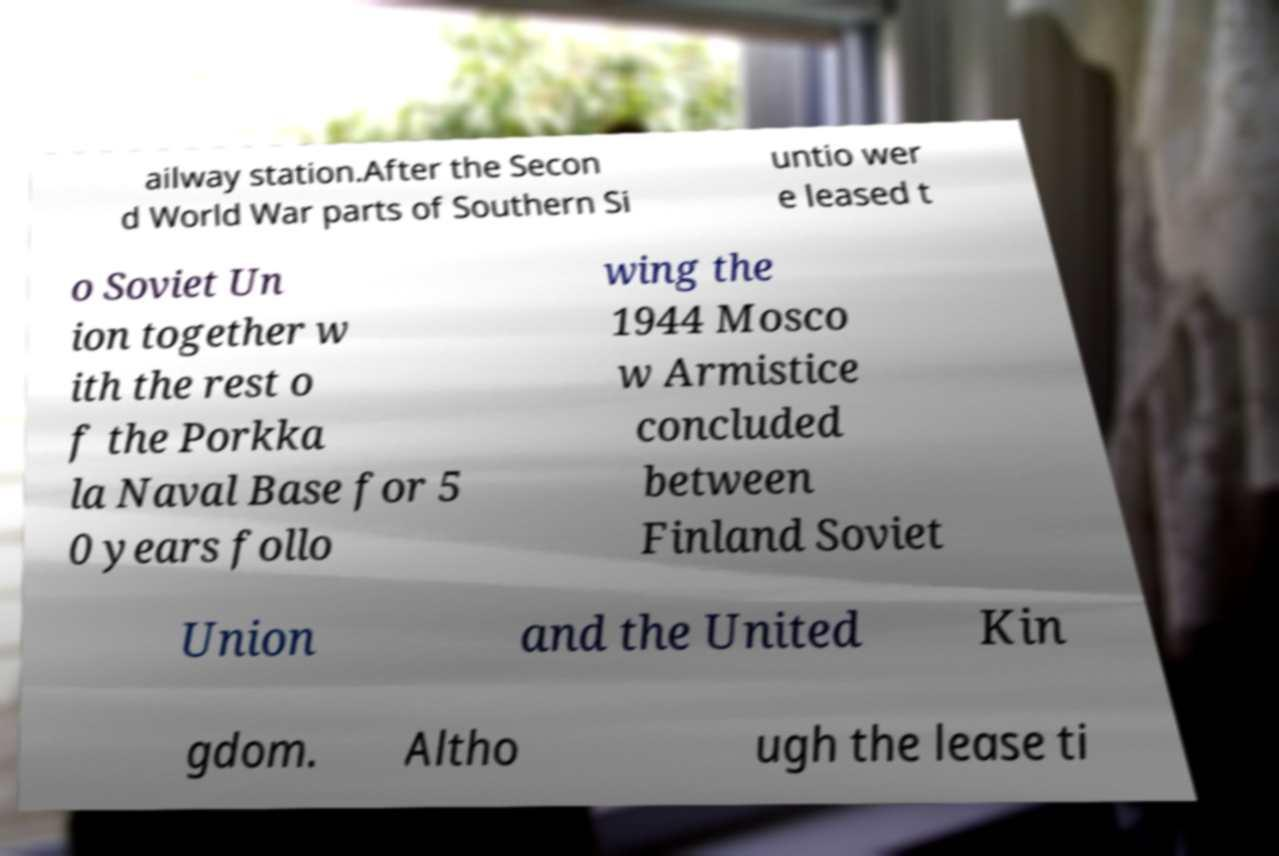Could you extract and type out the text from this image? ailway station.After the Secon d World War parts of Southern Si untio wer e leased t o Soviet Un ion together w ith the rest o f the Porkka la Naval Base for 5 0 years follo wing the 1944 Mosco w Armistice concluded between Finland Soviet Union and the United Kin gdom. Altho ugh the lease ti 